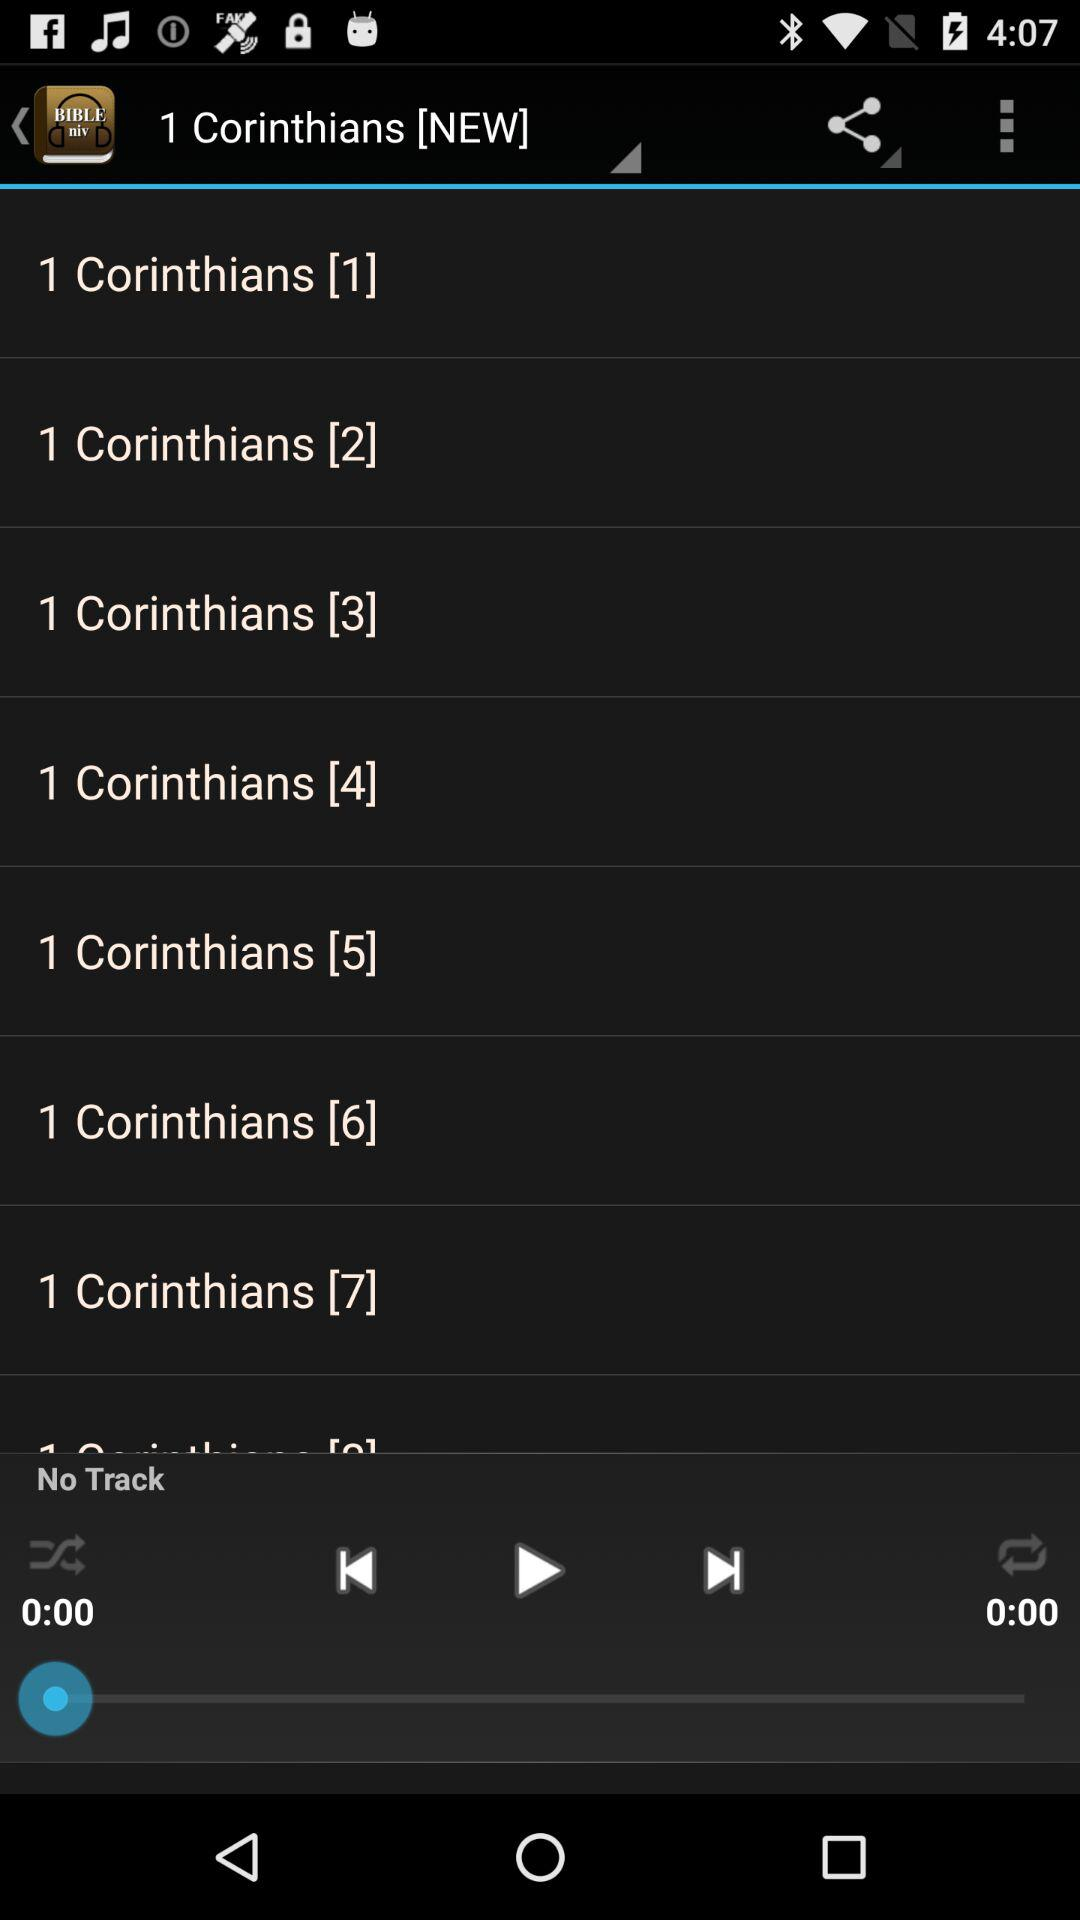Is there any track playing? There is no track playing. 